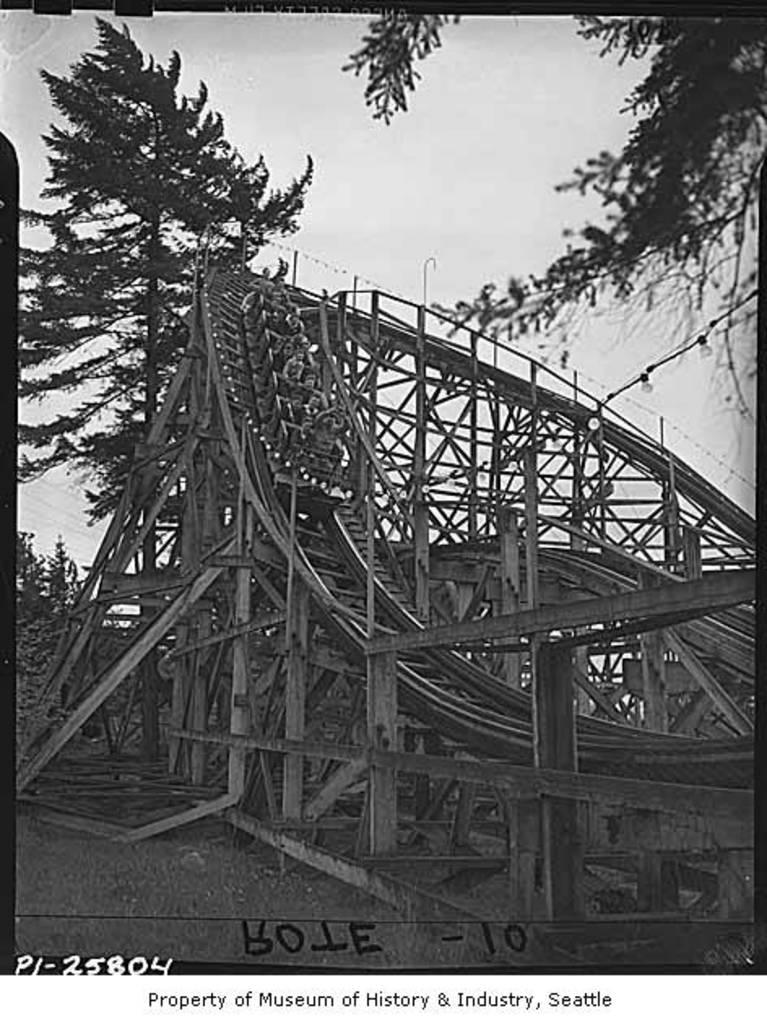What is the color scheme of the image? The image is black and white. What is the main subject of the image? There is a roller coaster in the image. What can be seen behind the roller coaster? Trees are visible behind the roller coaster. What is visible in the background of the image? The sky is visible in the image. Is there any text present in the image? Yes, there is text written on the image. What type of lettuce is being served at the school in the image? There is no school or lettuce present in the image; it features a black and white image of a roller coaster with trees and sky in the background. 